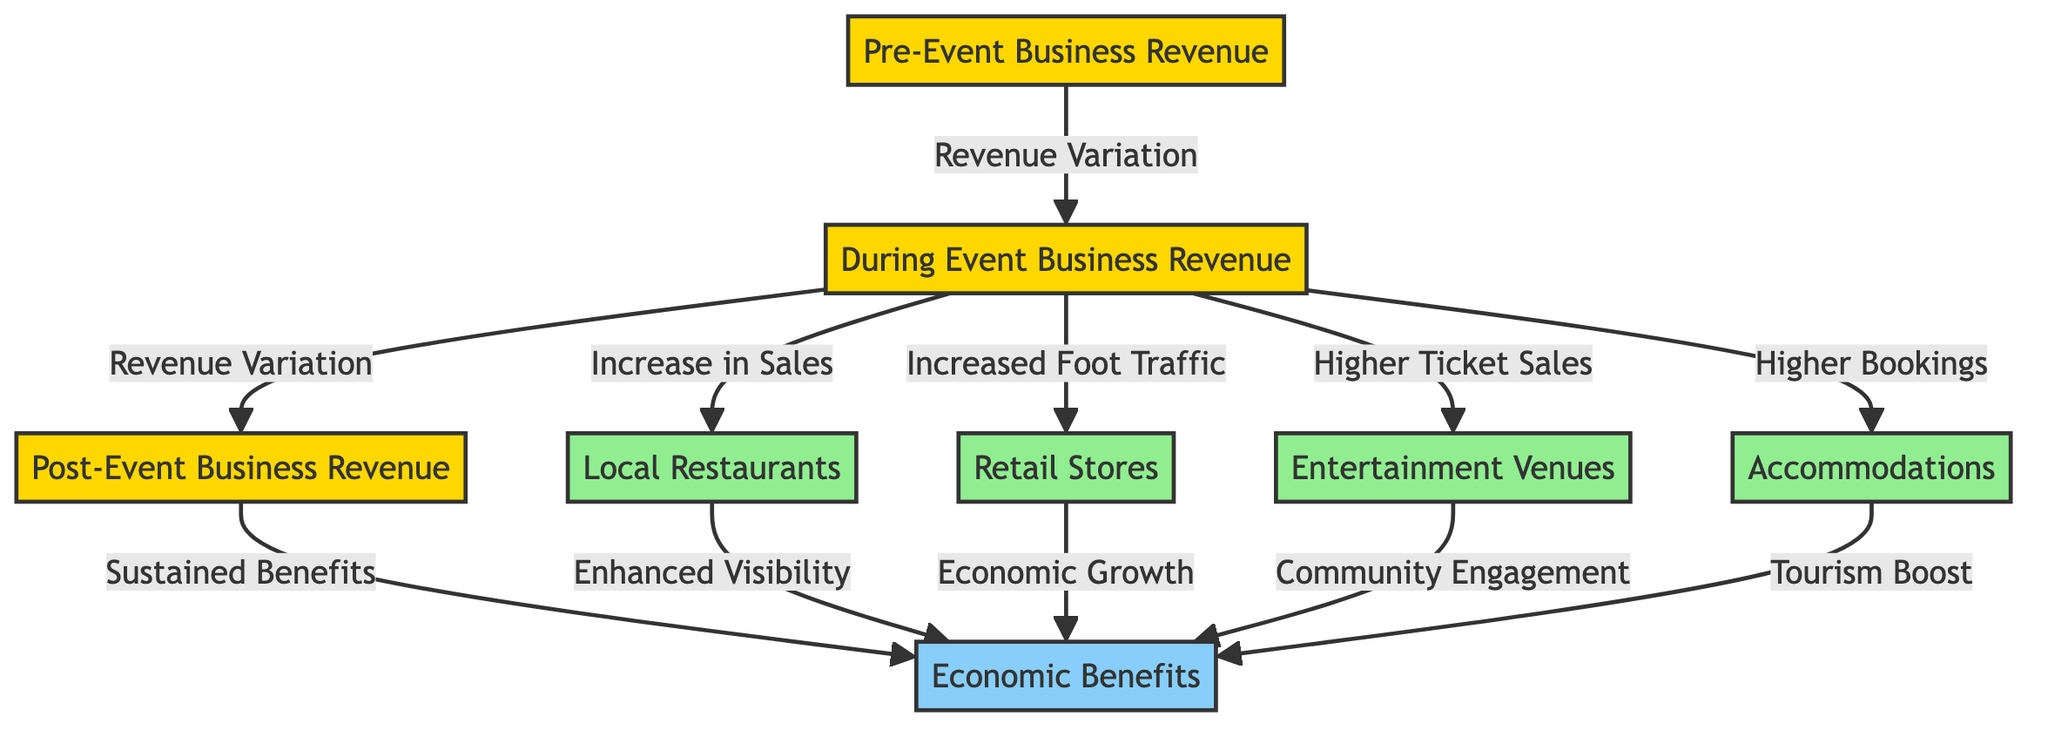What are the pre-event business revenues? The diagram lists "Pre-Event Business Revenue" as a node, which represents the baseline revenue. However, the diagram doesn't provide specific numbers, so it indicates that revenues exist but does not quantify them.
Answer: Pre-Event Business Revenue Which node represents business types affected during the event? The nodes "Local Restaurants," "Retail Stores," "Entertainment Venues," and "Accommodations" all represent types of businesses that see revenue changes during events as indicated by the arrows pointing from "During Event Business Revenue."
Answer: Local Restaurants, Retail Stores, Entertainment Venues, Accommodations What is indicated by the flow from "During Event Business Revenue" to "Post-Event Business Revenue"? This flow indicates that there is a variation in revenue from the event period to after the event, suggesting that some benefits may persist after the event is concluded.
Answer: Revenue Variation How does "During Event Business Revenue" affect "Local Restaurants"? The diagram shows an arrow from "During Event Business Revenue" to "Local Restaurants" tagged with "Increase in Sales," indicating a positive impact on restaurant revenues during events.
Answer: Increase in Sales What type of economic benefit is linked to "Higher Ticket Sales"? The connection in the diagram shows that "Higher Ticket Sales" leads to "Community Engagement," indicating an economic benefit associated with entertainment venues and audience participation during events.
Answer: Community Engagement What results from increased foot traffic according to the diagram? The arrow from "Increased Foot Traffic" points to "Retail Stores," suggesting that increased foot traffic directly correlates with improved sales for these businesses.
Answer: Economic Growth What sustains economic benefits after the event? The diagram indicates that the flow from "Post-Event Business Revenue" to "Economic Benefits" underlines the sustained impacts that events have on the economy.
Answer: Sustained Benefits How many business types are represented as affected during the event in the diagram? There are four business types listed: Local Restaurants, Retail Stores, Entertainment Venues, and Accommodations, which indicates a total of four types affected.
Answer: Four What overall effect do film events have on the local economy? The overall effect illustrated in the diagram goes from specific types of revenue variations during the event to broader economic benefits, highlighting a positive impact on the local economy.
Answer: Economic Benefits 